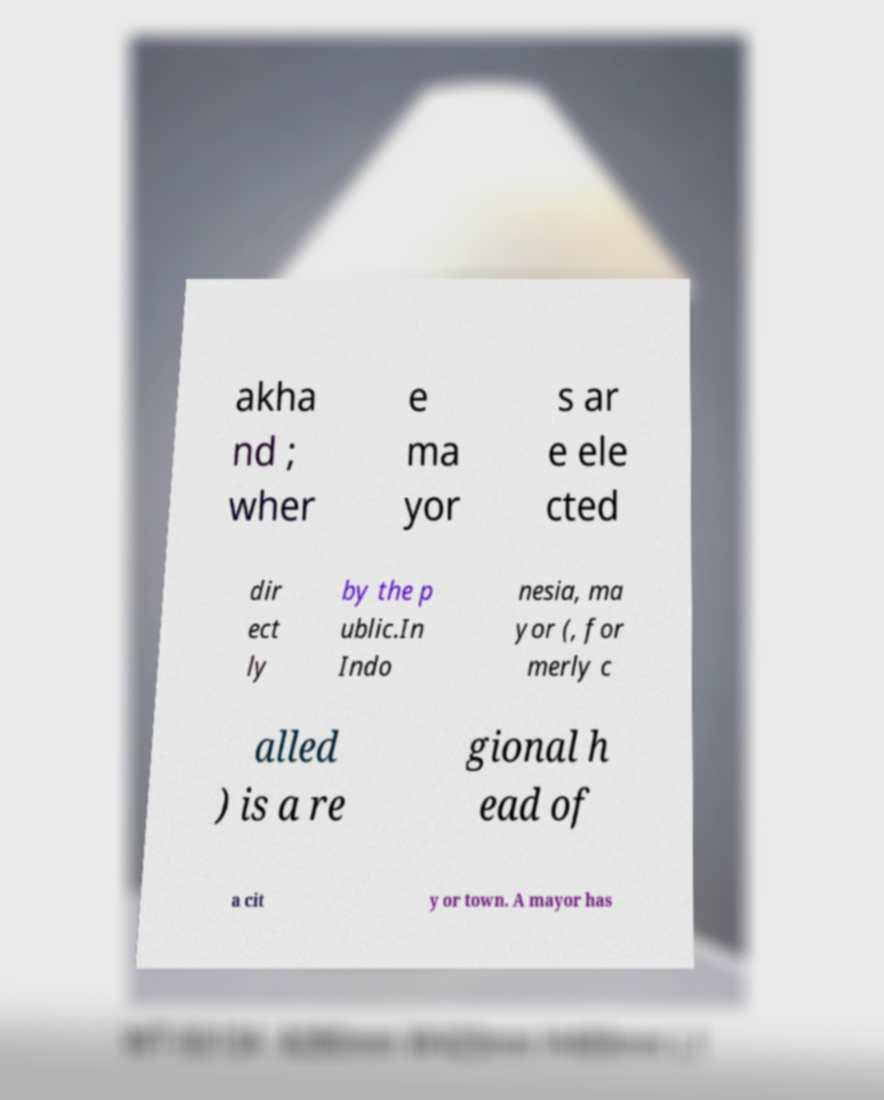Could you assist in decoding the text presented in this image and type it out clearly? akha nd ; wher e ma yor s ar e ele cted dir ect ly by the p ublic.In Indo nesia, ma yor (, for merly c alled ) is a re gional h ead of a cit y or town. A mayor has 